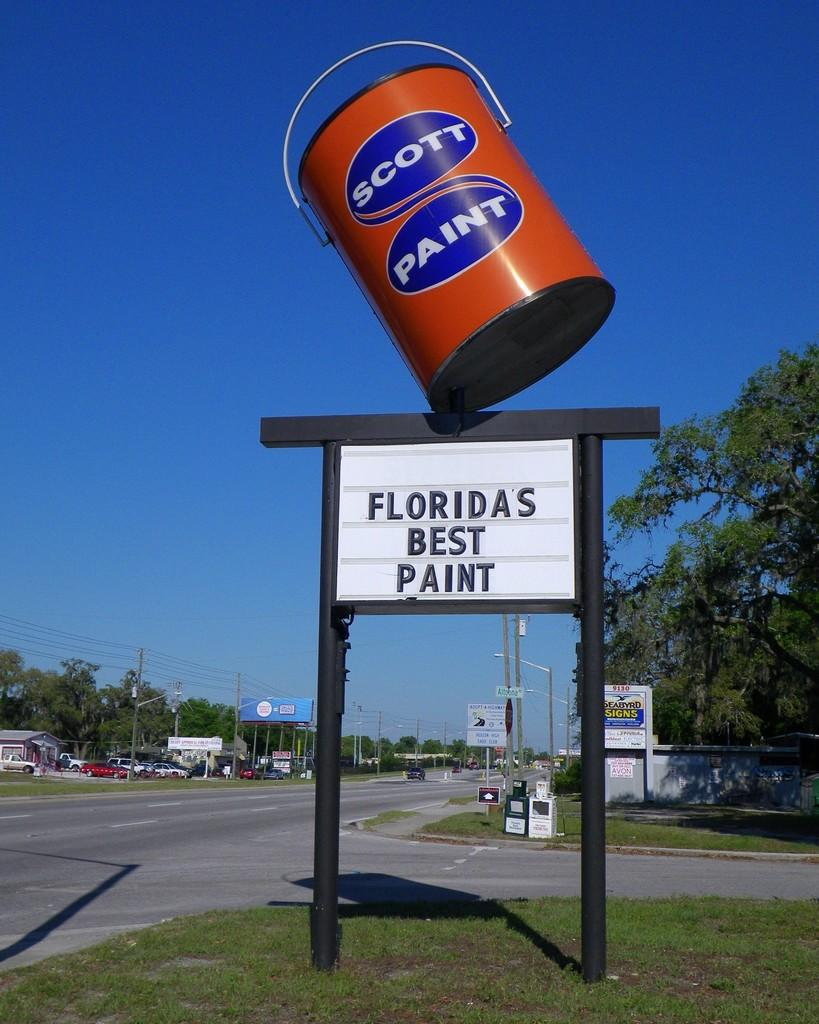<image>
Describe the image concisely. A sign for Scott Paint stating it is Florida's best paint. 